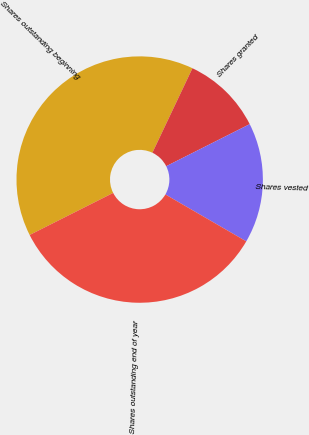<chart> <loc_0><loc_0><loc_500><loc_500><pie_chart><fcel>Shares outstanding beginning<fcel>Shares granted<fcel>Shares vested<fcel>Shares outstanding end of year<nl><fcel>39.47%<fcel>10.53%<fcel>15.79%<fcel>34.21%<nl></chart> 